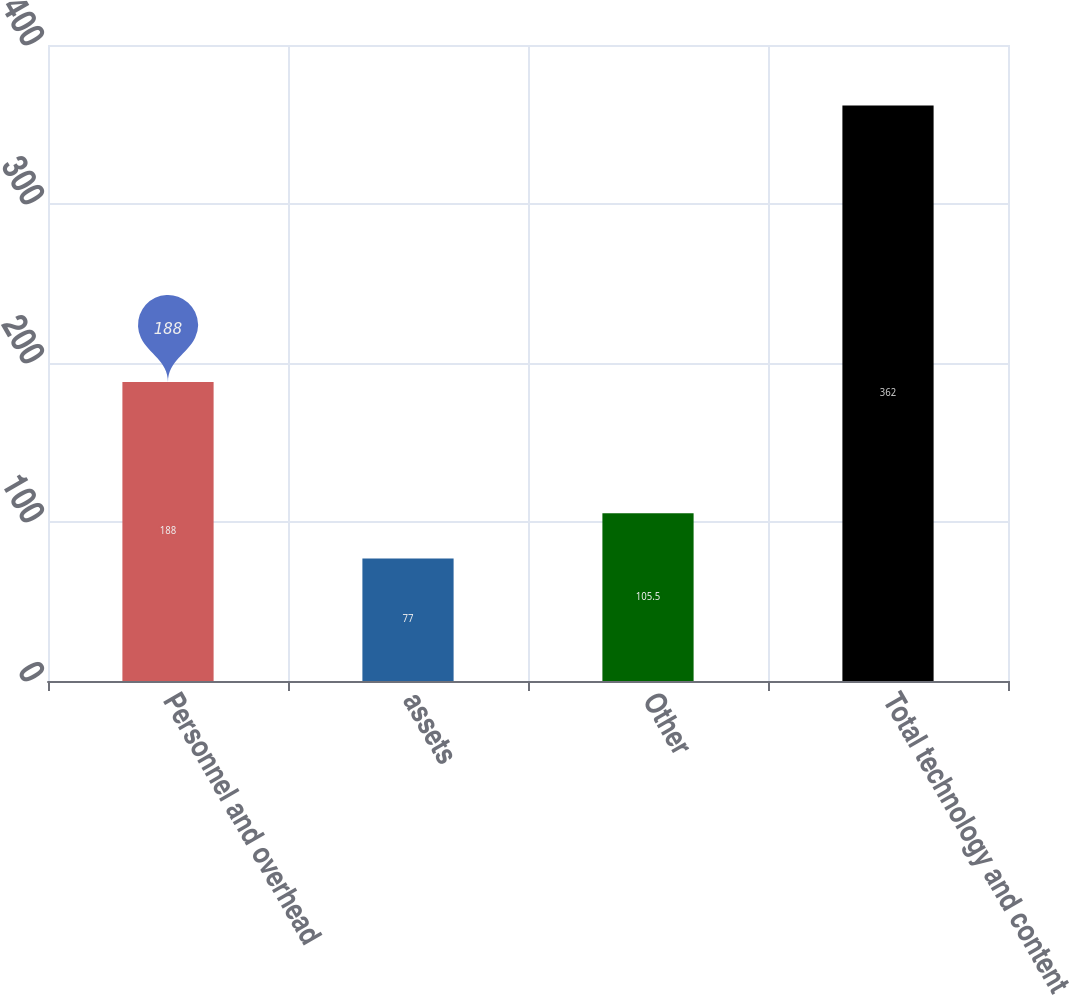Convert chart to OTSL. <chart><loc_0><loc_0><loc_500><loc_500><bar_chart><fcel>Personnel and overhead<fcel>assets<fcel>Other<fcel>Total technology and content<nl><fcel>188<fcel>77<fcel>105.5<fcel>362<nl></chart> 